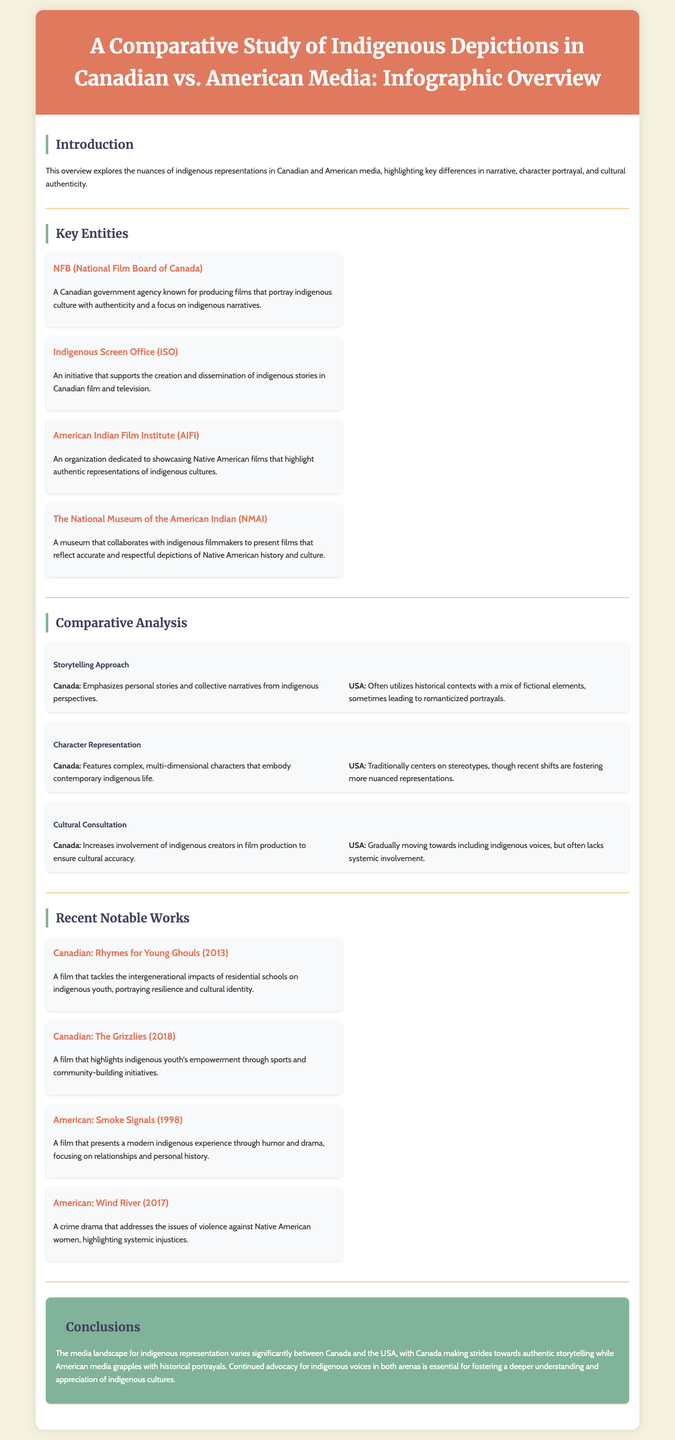What is the title of the document? The title is explicitly stated in the header of the document as "A Comparative Study of Indigenous Depictions in Canadian vs. American Media: Infographic Overview."
Answer: A Comparative Study of Indigenous Depictions in Canadian vs. American Media: Infographic Overview Which Canadian organization focuses on indigenous narratives? The document mentions the National Film Board of Canada as a key entity dedicated to authentic indigenous storytelling.
Answer: NFB (National Film Board of Canada) What storytelling approach does Canadian media emphasize? The document describes that Canadian media emphasizes personal stories and collective narratives from indigenous perspectives.
Answer: Personal stories and collective narratives Name one notable recent Canadian film mentioned in the document. The document lists "Rhymes for Young Ghouls (2013)" as a notable work in Canadian media.
Answer: Rhymes for Young Ghouls What aspect of media does the USA traditionally center on? According to the document, American media has traditionally centered on stereotypes in character representation.
Answer: Stereotypes What does the Indigenous Screen Office do? The document states that the Indigenous Screen Office supports the creation and dissemination of indigenous stories in Canadian film and television.
Answer: Supports creation and dissemination of indigenous stories How does the cultural consultation differ between Canada and the USA? The document indicates that Canada ensures greater involvement of indigenous creators for cultural accuracy, while the USA is gradually moving towards inclusion but often lacks systemic involvement.
Answer: Greater involvement in Canada, gradual move in USA What year was "Wind River" released? The document provides the release year of the film "Wind River" as 2017.
Answer: 2017 